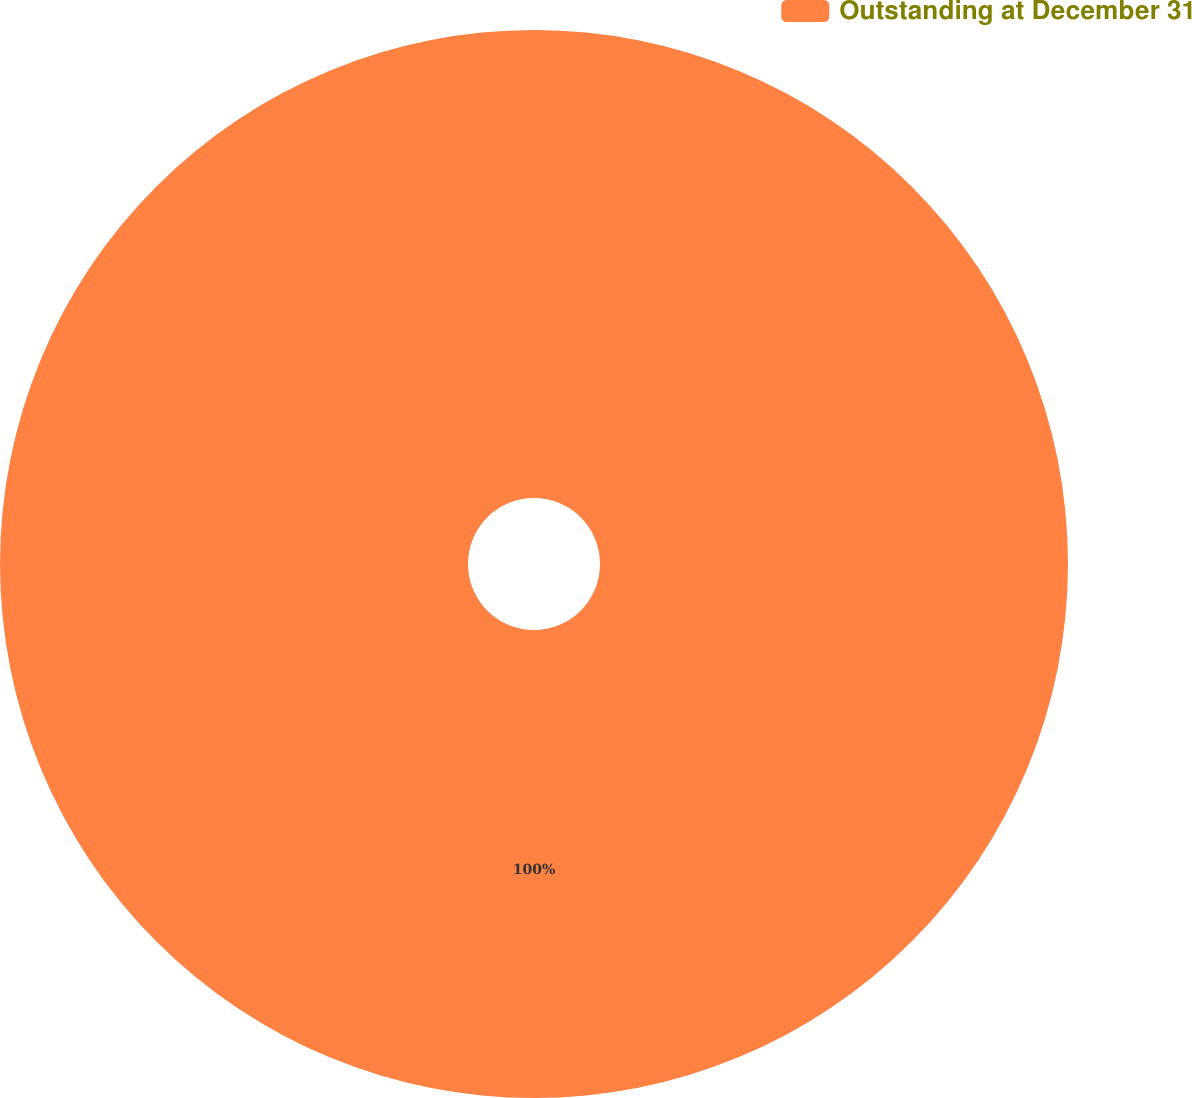Convert chart. <chart><loc_0><loc_0><loc_500><loc_500><pie_chart><fcel>Outstanding at December 31<nl><fcel>100.0%<nl></chart> 